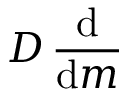<formula> <loc_0><loc_0><loc_500><loc_500>D \, { \frac { d } { d m } }</formula> 